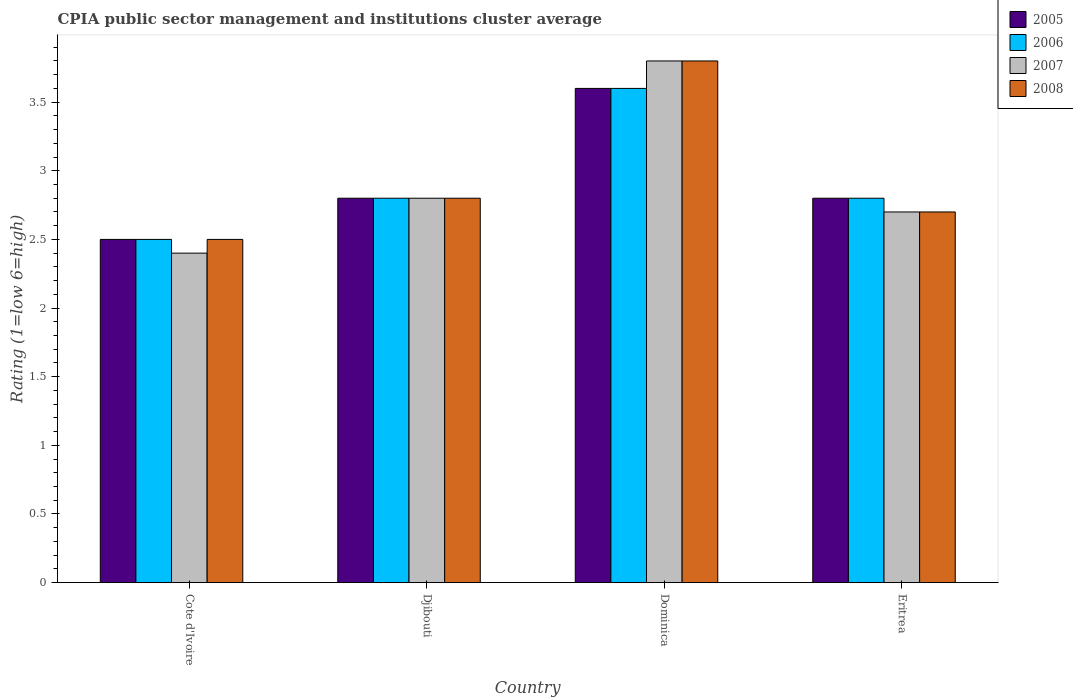How many groups of bars are there?
Keep it short and to the point. 4. What is the label of the 1st group of bars from the left?
Make the answer very short. Cote d'Ivoire. What is the CPIA rating in 2007 in Djibouti?
Your answer should be very brief. 2.8. Across all countries, what is the maximum CPIA rating in 2006?
Provide a succinct answer. 3.6. In which country was the CPIA rating in 2007 maximum?
Provide a succinct answer. Dominica. In which country was the CPIA rating in 2007 minimum?
Provide a succinct answer. Cote d'Ivoire. What is the difference between the CPIA rating in 2005 in Cote d'Ivoire and that in Dominica?
Your answer should be very brief. -1.1. What is the difference between the CPIA rating in 2008 in Djibouti and the CPIA rating in 2005 in Cote d'Ivoire?
Provide a succinct answer. 0.3. What is the average CPIA rating in 2005 per country?
Provide a short and direct response. 2.92. In how many countries, is the CPIA rating in 2007 greater than 0.2?
Make the answer very short. 4. What is the ratio of the CPIA rating in 2008 in Dominica to that in Eritrea?
Provide a succinct answer. 1.41. What is the difference between the highest and the second highest CPIA rating in 2008?
Your response must be concise. -1. What is the difference between the highest and the lowest CPIA rating in 2007?
Your answer should be compact. 1.4. In how many countries, is the CPIA rating in 2006 greater than the average CPIA rating in 2006 taken over all countries?
Offer a terse response. 1. Is it the case that in every country, the sum of the CPIA rating in 2007 and CPIA rating in 2006 is greater than the CPIA rating in 2008?
Your answer should be very brief. Yes. How many bars are there?
Make the answer very short. 16. Are all the bars in the graph horizontal?
Keep it short and to the point. No. How many countries are there in the graph?
Make the answer very short. 4. Are the values on the major ticks of Y-axis written in scientific E-notation?
Provide a short and direct response. No. Does the graph contain any zero values?
Your answer should be very brief. No. Where does the legend appear in the graph?
Your answer should be compact. Top right. What is the title of the graph?
Give a very brief answer. CPIA public sector management and institutions cluster average. Does "2015" appear as one of the legend labels in the graph?
Offer a very short reply. No. What is the label or title of the X-axis?
Provide a short and direct response. Country. What is the Rating (1=low 6=high) of 2005 in Djibouti?
Make the answer very short. 2.8. What is the Rating (1=low 6=high) in 2006 in Djibouti?
Ensure brevity in your answer.  2.8. What is the Rating (1=low 6=high) in 2008 in Djibouti?
Provide a succinct answer. 2.8. What is the Rating (1=low 6=high) in 2007 in Dominica?
Make the answer very short. 3.8. What is the Rating (1=low 6=high) of 2008 in Dominica?
Provide a short and direct response. 3.8. What is the Rating (1=low 6=high) in 2006 in Eritrea?
Your response must be concise. 2.8. What is the Rating (1=low 6=high) of 2008 in Eritrea?
Your response must be concise. 2.7. Across all countries, what is the maximum Rating (1=low 6=high) of 2005?
Make the answer very short. 3.6. Across all countries, what is the minimum Rating (1=low 6=high) of 2005?
Your response must be concise. 2.5. Across all countries, what is the minimum Rating (1=low 6=high) in 2007?
Your response must be concise. 2.4. Across all countries, what is the minimum Rating (1=low 6=high) in 2008?
Your answer should be compact. 2.5. What is the total Rating (1=low 6=high) of 2006 in the graph?
Keep it short and to the point. 11.7. What is the difference between the Rating (1=low 6=high) in 2005 in Cote d'Ivoire and that in Djibouti?
Give a very brief answer. -0.3. What is the difference between the Rating (1=low 6=high) in 2007 in Cote d'Ivoire and that in Djibouti?
Keep it short and to the point. -0.4. What is the difference between the Rating (1=low 6=high) in 2005 in Cote d'Ivoire and that in Dominica?
Give a very brief answer. -1.1. What is the difference between the Rating (1=low 6=high) of 2008 in Cote d'Ivoire and that in Dominica?
Provide a short and direct response. -1.3. What is the difference between the Rating (1=low 6=high) of 2005 in Cote d'Ivoire and that in Eritrea?
Make the answer very short. -0.3. What is the difference between the Rating (1=low 6=high) of 2006 in Cote d'Ivoire and that in Eritrea?
Offer a terse response. -0.3. What is the difference between the Rating (1=low 6=high) in 2007 in Cote d'Ivoire and that in Eritrea?
Make the answer very short. -0.3. What is the difference between the Rating (1=low 6=high) in 2008 in Cote d'Ivoire and that in Eritrea?
Provide a short and direct response. -0.2. What is the difference between the Rating (1=low 6=high) of 2005 in Djibouti and that in Eritrea?
Ensure brevity in your answer.  0. What is the difference between the Rating (1=low 6=high) of 2006 in Djibouti and that in Eritrea?
Your answer should be very brief. 0. What is the difference between the Rating (1=low 6=high) in 2007 in Djibouti and that in Eritrea?
Ensure brevity in your answer.  0.1. What is the difference between the Rating (1=low 6=high) of 2008 in Djibouti and that in Eritrea?
Give a very brief answer. 0.1. What is the difference between the Rating (1=low 6=high) of 2006 in Dominica and that in Eritrea?
Provide a short and direct response. 0.8. What is the difference between the Rating (1=low 6=high) of 2005 in Cote d'Ivoire and the Rating (1=low 6=high) of 2006 in Djibouti?
Your response must be concise. -0.3. What is the difference between the Rating (1=low 6=high) of 2006 in Cote d'Ivoire and the Rating (1=low 6=high) of 2008 in Djibouti?
Ensure brevity in your answer.  -0.3. What is the difference between the Rating (1=low 6=high) of 2005 in Cote d'Ivoire and the Rating (1=low 6=high) of 2008 in Dominica?
Offer a very short reply. -1.3. What is the difference between the Rating (1=low 6=high) in 2006 in Cote d'Ivoire and the Rating (1=low 6=high) in 2008 in Dominica?
Provide a short and direct response. -1.3. What is the difference between the Rating (1=low 6=high) in 2007 in Cote d'Ivoire and the Rating (1=low 6=high) in 2008 in Dominica?
Provide a short and direct response. -1.4. What is the difference between the Rating (1=low 6=high) in 2005 in Cote d'Ivoire and the Rating (1=low 6=high) in 2007 in Eritrea?
Make the answer very short. -0.2. What is the difference between the Rating (1=low 6=high) of 2005 in Cote d'Ivoire and the Rating (1=low 6=high) of 2008 in Eritrea?
Offer a terse response. -0.2. What is the difference between the Rating (1=low 6=high) of 2006 in Cote d'Ivoire and the Rating (1=low 6=high) of 2007 in Eritrea?
Offer a terse response. -0.2. What is the difference between the Rating (1=low 6=high) in 2005 in Djibouti and the Rating (1=low 6=high) in 2007 in Dominica?
Offer a very short reply. -1. What is the difference between the Rating (1=low 6=high) of 2006 in Djibouti and the Rating (1=low 6=high) of 2007 in Dominica?
Provide a short and direct response. -1. What is the difference between the Rating (1=low 6=high) in 2006 in Djibouti and the Rating (1=low 6=high) in 2008 in Dominica?
Ensure brevity in your answer.  -1. What is the difference between the Rating (1=low 6=high) in 2005 in Djibouti and the Rating (1=low 6=high) in 2007 in Eritrea?
Offer a terse response. 0.1. What is the difference between the Rating (1=low 6=high) in 2006 in Djibouti and the Rating (1=low 6=high) in 2008 in Eritrea?
Offer a terse response. 0.1. What is the difference between the Rating (1=low 6=high) of 2007 in Djibouti and the Rating (1=low 6=high) of 2008 in Eritrea?
Your answer should be very brief. 0.1. What is the difference between the Rating (1=low 6=high) in 2005 in Dominica and the Rating (1=low 6=high) in 2008 in Eritrea?
Give a very brief answer. 0.9. What is the difference between the Rating (1=low 6=high) in 2006 in Dominica and the Rating (1=low 6=high) in 2007 in Eritrea?
Keep it short and to the point. 0.9. What is the difference between the Rating (1=low 6=high) of 2007 in Dominica and the Rating (1=low 6=high) of 2008 in Eritrea?
Offer a terse response. 1.1. What is the average Rating (1=low 6=high) of 2005 per country?
Ensure brevity in your answer.  2.92. What is the average Rating (1=low 6=high) in 2006 per country?
Your answer should be compact. 2.92. What is the average Rating (1=low 6=high) of 2007 per country?
Offer a terse response. 2.92. What is the average Rating (1=low 6=high) in 2008 per country?
Provide a short and direct response. 2.95. What is the difference between the Rating (1=low 6=high) in 2005 and Rating (1=low 6=high) in 2007 in Cote d'Ivoire?
Offer a very short reply. 0.1. What is the difference between the Rating (1=low 6=high) in 2005 and Rating (1=low 6=high) in 2008 in Cote d'Ivoire?
Offer a very short reply. 0. What is the difference between the Rating (1=low 6=high) in 2007 and Rating (1=low 6=high) in 2008 in Cote d'Ivoire?
Provide a short and direct response. -0.1. What is the difference between the Rating (1=low 6=high) in 2005 and Rating (1=low 6=high) in 2006 in Djibouti?
Offer a very short reply. 0. What is the difference between the Rating (1=low 6=high) in 2005 and Rating (1=low 6=high) in 2007 in Dominica?
Your response must be concise. -0.2. What is the difference between the Rating (1=low 6=high) of 2006 and Rating (1=low 6=high) of 2007 in Dominica?
Keep it short and to the point. -0.2. What is the difference between the Rating (1=low 6=high) in 2006 and Rating (1=low 6=high) in 2008 in Dominica?
Ensure brevity in your answer.  -0.2. What is the difference between the Rating (1=low 6=high) in 2007 and Rating (1=low 6=high) in 2008 in Dominica?
Your answer should be very brief. 0. What is the difference between the Rating (1=low 6=high) in 2005 and Rating (1=low 6=high) in 2007 in Eritrea?
Provide a succinct answer. 0.1. What is the difference between the Rating (1=low 6=high) of 2005 and Rating (1=low 6=high) of 2008 in Eritrea?
Offer a terse response. 0.1. What is the difference between the Rating (1=low 6=high) of 2006 and Rating (1=low 6=high) of 2007 in Eritrea?
Offer a terse response. 0.1. What is the difference between the Rating (1=low 6=high) of 2006 and Rating (1=low 6=high) of 2008 in Eritrea?
Your answer should be compact. 0.1. What is the difference between the Rating (1=low 6=high) of 2007 and Rating (1=low 6=high) of 2008 in Eritrea?
Keep it short and to the point. 0. What is the ratio of the Rating (1=low 6=high) in 2005 in Cote d'Ivoire to that in Djibouti?
Make the answer very short. 0.89. What is the ratio of the Rating (1=low 6=high) in 2006 in Cote d'Ivoire to that in Djibouti?
Your response must be concise. 0.89. What is the ratio of the Rating (1=low 6=high) of 2007 in Cote d'Ivoire to that in Djibouti?
Keep it short and to the point. 0.86. What is the ratio of the Rating (1=low 6=high) of 2008 in Cote d'Ivoire to that in Djibouti?
Offer a very short reply. 0.89. What is the ratio of the Rating (1=low 6=high) of 2005 in Cote d'Ivoire to that in Dominica?
Your answer should be compact. 0.69. What is the ratio of the Rating (1=low 6=high) in 2006 in Cote d'Ivoire to that in Dominica?
Your response must be concise. 0.69. What is the ratio of the Rating (1=low 6=high) of 2007 in Cote d'Ivoire to that in Dominica?
Keep it short and to the point. 0.63. What is the ratio of the Rating (1=low 6=high) of 2008 in Cote d'Ivoire to that in Dominica?
Give a very brief answer. 0.66. What is the ratio of the Rating (1=low 6=high) in 2005 in Cote d'Ivoire to that in Eritrea?
Provide a short and direct response. 0.89. What is the ratio of the Rating (1=low 6=high) in 2006 in Cote d'Ivoire to that in Eritrea?
Make the answer very short. 0.89. What is the ratio of the Rating (1=low 6=high) in 2007 in Cote d'Ivoire to that in Eritrea?
Keep it short and to the point. 0.89. What is the ratio of the Rating (1=low 6=high) of 2008 in Cote d'Ivoire to that in Eritrea?
Provide a short and direct response. 0.93. What is the ratio of the Rating (1=low 6=high) of 2006 in Djibouti to that in Dominica?
Your answer should be very brief. 0.78. What is the ratio of the Rating (1=low 6=high) in 2007 in Djibouti to that in Dominica?
Give a very brief answer. 0.74. What is the ratio of the Rating (1=low 6=high) in 2008 in Djibouti to that in Dominica?
Your answer should be compact. 0.74. What is the ratio of the Rating (1=low 6=high) of 2007 in Djibouti to that in Eritrea?
Your answer should be compact. 1.04. What is the ratio of the Rating (1=low 6=high) of 2008 in Djibouti to that in Eritrea?
Make the answer very short. 1.04. What is the ratio of the Rating (1=low 6=high) in 2007 in Dominica to that in Eritrea?
Your answer should be compact. 1.41. What is the ratio of the Rating (1=low 6=high) of 2008 in Dominica to that in Eritrea?
Keep it short and to the point. 1.41. What is the difference between the highest and the second highest Rating (1=low 6=high) of 2007?
Give a very brief answer. 1. What is the difference between the highest and the second highest Rating (1=low 6=high) in 2008?
Keep it short and to the point. 1. What is the difference between the highest and the lowest Rating (1=low 6=high) in 2006?
Ensure brevity in your answer.  1.1. What is the difference between the highest and the lowest Rating (1=low 6=high) in 2008?
Give a very brief answer. 1.3. 